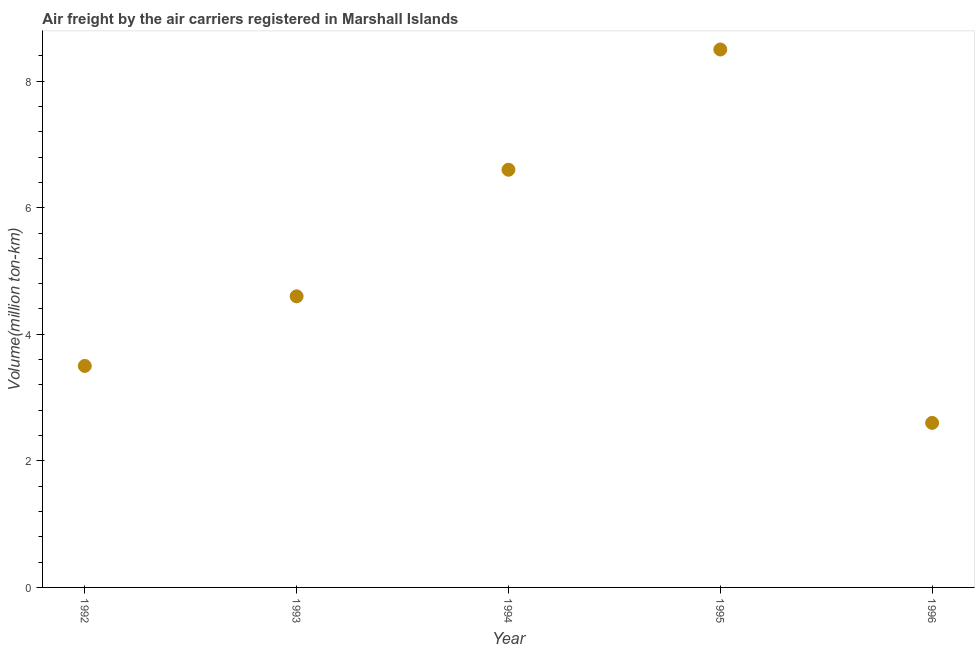What is the air freight in 1994?
Your answer should be very brief. 6.6. Across all years, what is the minimum air freight?
Offer a terse response. 2.6. What is the sum of the air freight?
Provide a succinct answer. 25.8. What is the difference between the air freight in 1995 and 1996?
Give a very brief answer. 5.9. What is the average air freight per year?
Your answer should be compact. 5.16. What is the median air freight?
Give a very brief answer. 4.6. What is the ratio of the air freight in 1992 to that in 1996?
Offer a terse response. 1.35. Is the difference between the air freight in 1993 and 1996 greater than the difference between any two years?
Make the answer very short. No. What is the difference between the highest and the second highest air freight?
Keep it short and to the point. 1.9. Is the sum of the air freight in 1992 and 1996 greater than the maximum air freight across all years?
Provide a succinct answer. No. What is the difference between the highest and the lowest air freight?
Make the answer very short. 5.9. In how many years, is the air freight greater than the average air freight taken over all years?
Keep it short and to the point. 2. Does the air freight monotonically increase over the years?
Ensure brevity in your answer.  No. How many years are there in the graph?
Offer a terse response. 5. Are the values on the major ticks of Y-axis written in scientific E-notation?
Make the answer very short. No. Does the graph contain any zero values?
Your answer should be very brief. No. What is the title of the graph?
Ensure brevity in your answer.  Air freight by the air carriers registered in Marshall Islands. What is the label or title of the Y-axis?
Make the answer very short. Volume(million ton-km). What is the Volume(million ton-km) in 1992?
Offer a terse response. 3.5. What is the Volume(million ton-km) in 1993?
Your answer should be compact. 4.6. What is the Volume(million ton-km) in 1994?
Your response must be concise. 6.6. What is the Volume(million ton-km) in 1995?
Provide a short and direct response. 8.5. What is the Volume(million ton-km) in 1996?
Provide a succinct answer. 2.6. What is the difference between the Volume(million ton-km) in 1992 and 1993?
Ensure brevity in your answer.  -1.1. What is the difference between the Volume(million ton-km) in 1992 and 1995?
Keep it short and to the point. -5. What is the difference between the Volume(million ton-km) in 1992 and 1996?
Your response must be concise. 0.9. What is the difference between the Volume(million ton-km) in 1993 and 1994?
Give a very brief answer. -2. What is the difference between the Volume(million ton-km) in 1993 and 1996?
Provide a succinct answer. 2. What is the difference between the Volume(million ton-km) in 1995 and 1996?
Offer a terse response. 5.9. What is the ratio of the Volume(million ton-km) in 1992 to that in 1993?
Provide a short and direct response. 0.76. What is the ratio of the Volume(million ton-km) in 1992 to that in 1994?
Keep it short and to the point. 0.53. What is the ratio of the Volume(million ton-km) in 1992 to that in 1995?
Provide a short and direct response. 0.41. What is the ratio of the Volume(million ton-km) in 1992 to that in 1996?
Ensure brevity in your answer.  1.35. What is the ratio of the Volume(million ton-km) in 1993 to that in 1994?
Your response must be concise. 0.7. What is the ratio of the Volume(million ton-km) in 1993 to that in 1995?
Your response must be concise. 0.54. What is the ratio of the Volume(million ton-km) in 1993 to that in 1996?
Offer a terse response. 1.77. What is the ratio of the Volume(million ton-km) in 1994 to that in 1995?
Your response must be concise. 0.78. What is the ratio of the Volume(million ton-km) in 1994 to that in 1996?
Provide a succinct answer. 2.54. What is the ratio of the Volume(million ton-km) in 1995 to that in 1996?
Give a very brief answer. 3.27. 